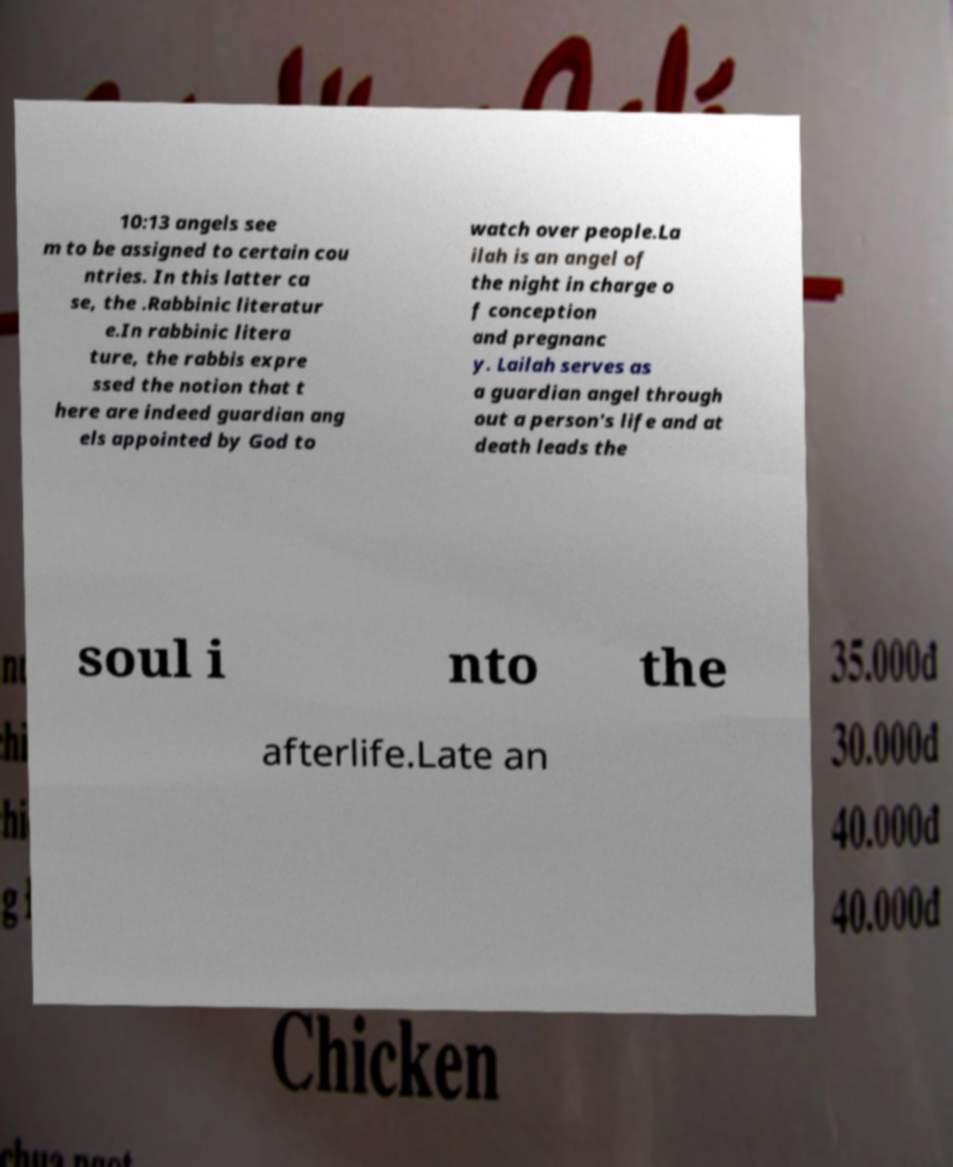Please read and relay the text visible in this image. What does it say? 10:13 angels see m to be assigned to certain cou ntries. In this latter ca se, the .Rabbinic literatur e.In rabbinic litera ture, the rabbis expre ssed the notion that t here are indeed guardian ang els appointed by God to watch over people.La ilah is an angel of the night in charge o f conception and pregnanc y. Lailah serves as a guardian angel through out a person's life and at death leads the soul i nto the afterlife.Late an 